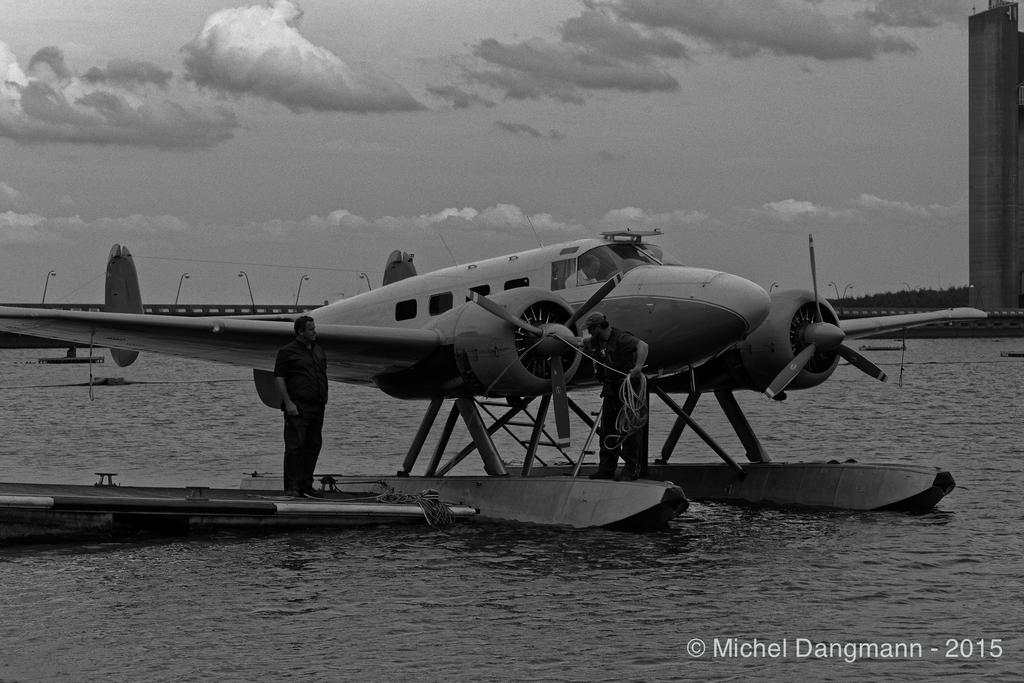When was the photo taken?
Give a very brief answer. 2015. 